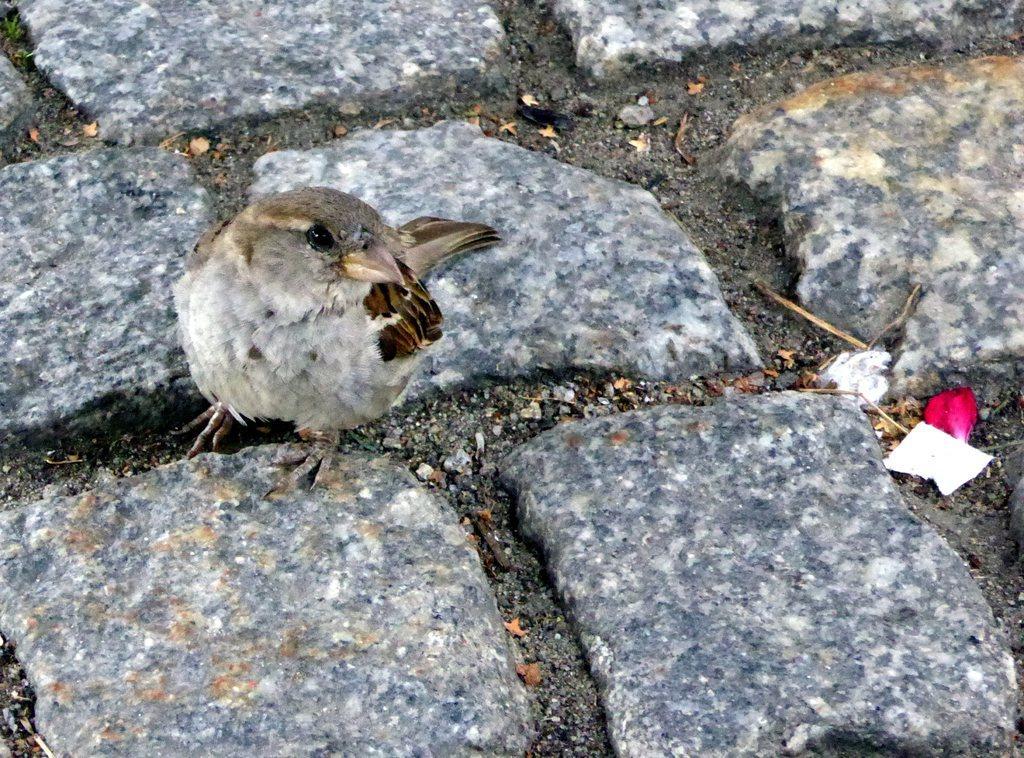Please provide a concise description of this image. In this image there is a bird, dust particles on the rock stones. 